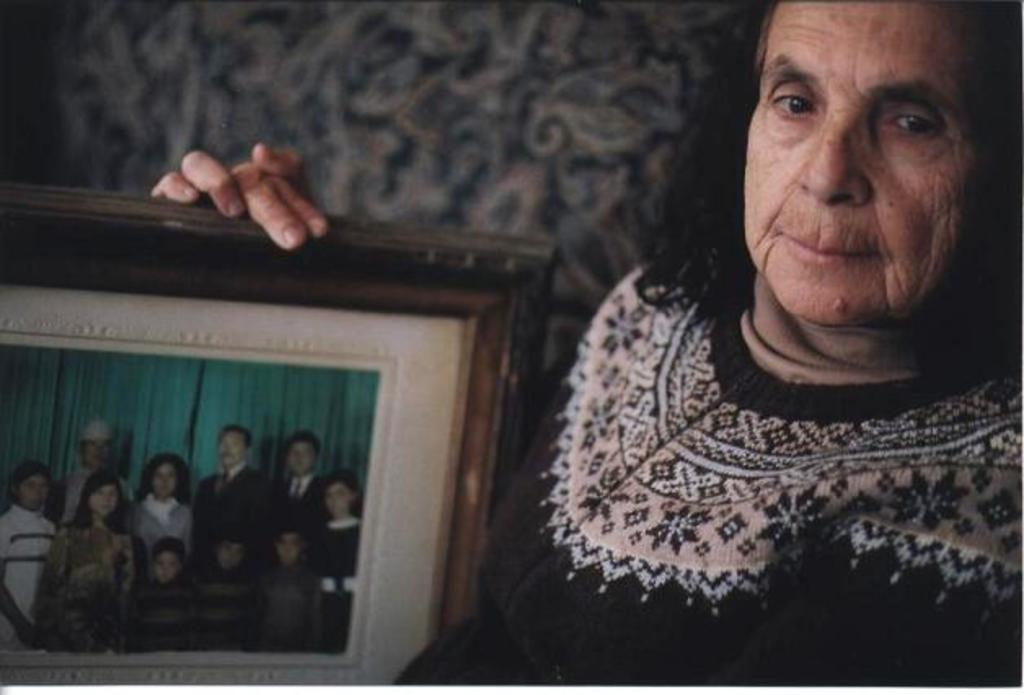Describe this image in one or two sentences. In the image a woman is standing and holding a photo frame. Behind her there is wall. 